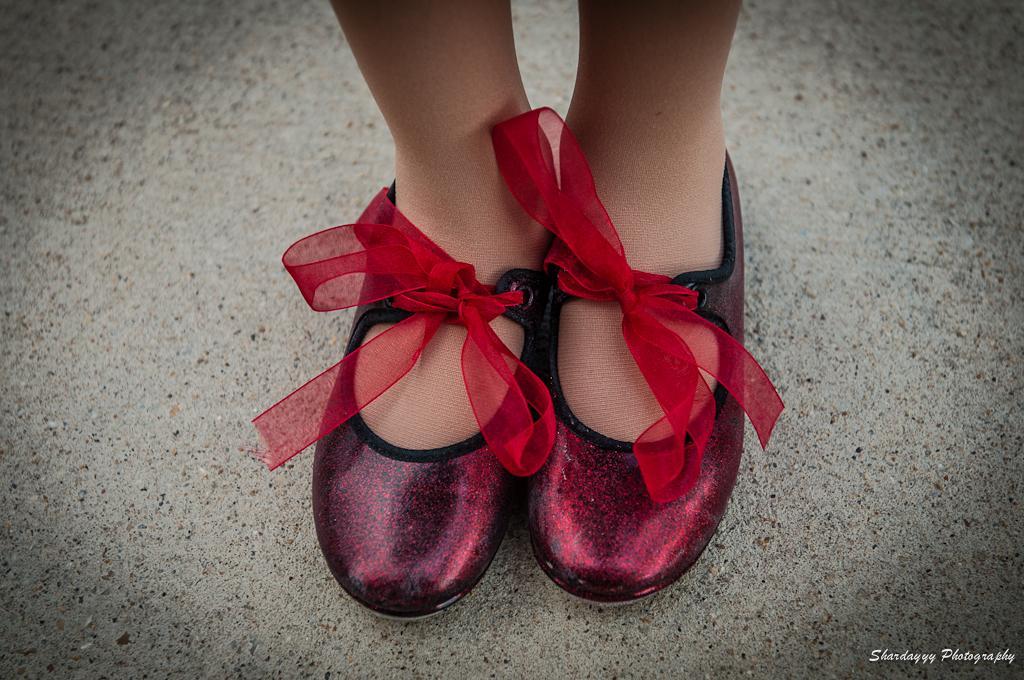Could you give a brief overview of what you see in this image? This image consists of a girl wearing shoes. The shoes are in red color. To that there are red colored ribbons. At the bottom, there is road. 